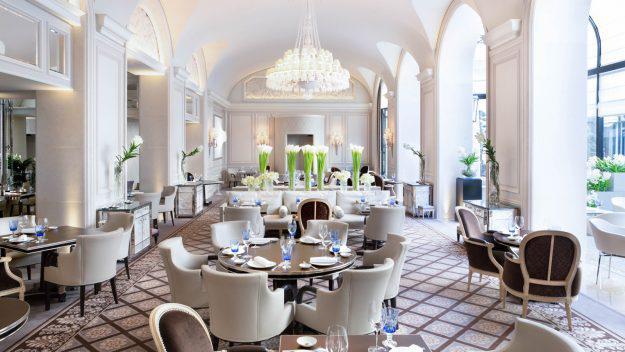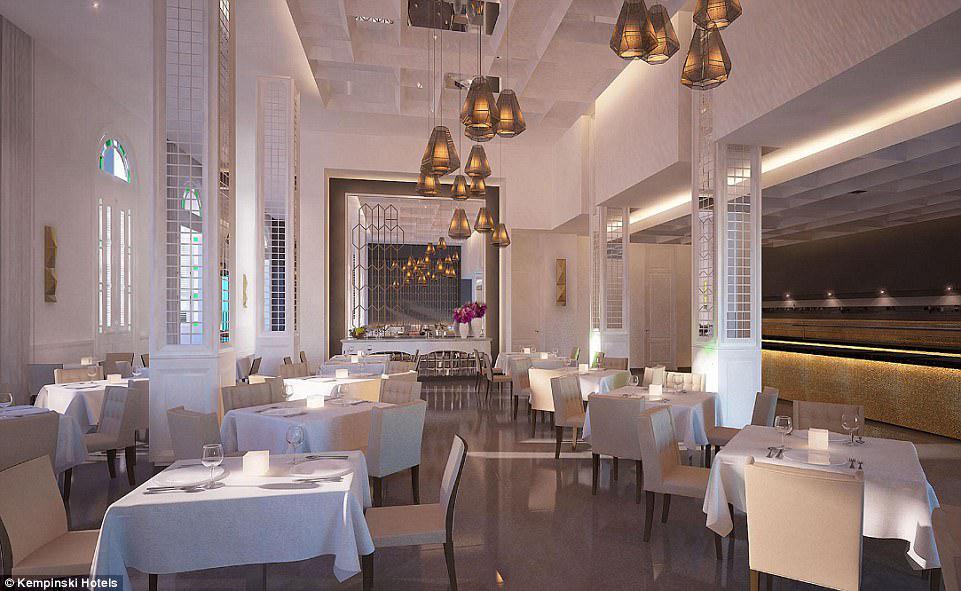The first image is the image on the left, the second image is the image on the right. Assess this claim about the two images: "An exterior features a row of dark gray planters containing spiky green plants, in front of tables where customers are sitting, which are in front of a recessed window with a string of lights over it.". Correct or not? Answer yes or no. No. The first image is the image on the left, the second image is the image on the right. Analyze the images presented: Is the assertion "One image shows both bar- and table-seating inside a restaurant, while a second image shows outdoor table seating." valid? Answer yes or no. No. 